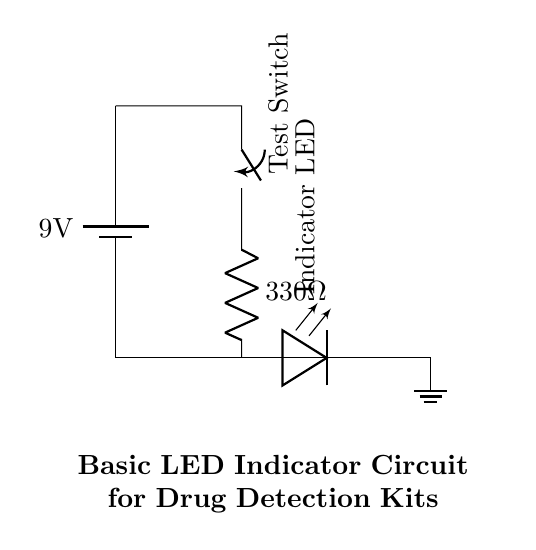What is the voltage of the power supply? The circuit diagram indicates a battery as the power source with a label showing it provides a voltage of 9 volts.
Answer: 9 volts What component limits the current to the LED? The circuit includes a resistor labeled with a value of 330 ohms, which is specifically used to limit the amount of current flowing through the LED to prevent it from burning out.
Answer: 330 ohms How many main components are shown in the circuit? The circuit features four main components: a battery, a switch, a resistor, and an LED, all of which are labeled clearly in the diagram.
Answer: Four What type of switch is used in this circuit? The diagram specifically labels the switch as a "Test Switch," which indicates its function in the circuit to turn on and off the current flow for testing purposes.
Answer: Test Switch What is the purpose of the LED in this circuit? The LED is labeled as an "Indicator LED," implying that its role is to visually indicate the presence of voltage or the operational status of the circuit once the switch is activated.
Answer: Indicator What would happen if the switch is closed? Closing the switch completes the circuit, allowing current to flow from the battery through the resistor and LED, which would cause the LED to light up as an indication of the circuit's operational state.
Answer: LED lights up What is the purpose of the ground connection in this circuit? The ground connection provides a reference point for the circuit and completes the electrical circuit, ensuring proper operation by allowing current to flow back to the battery.
Answer: Reference point 